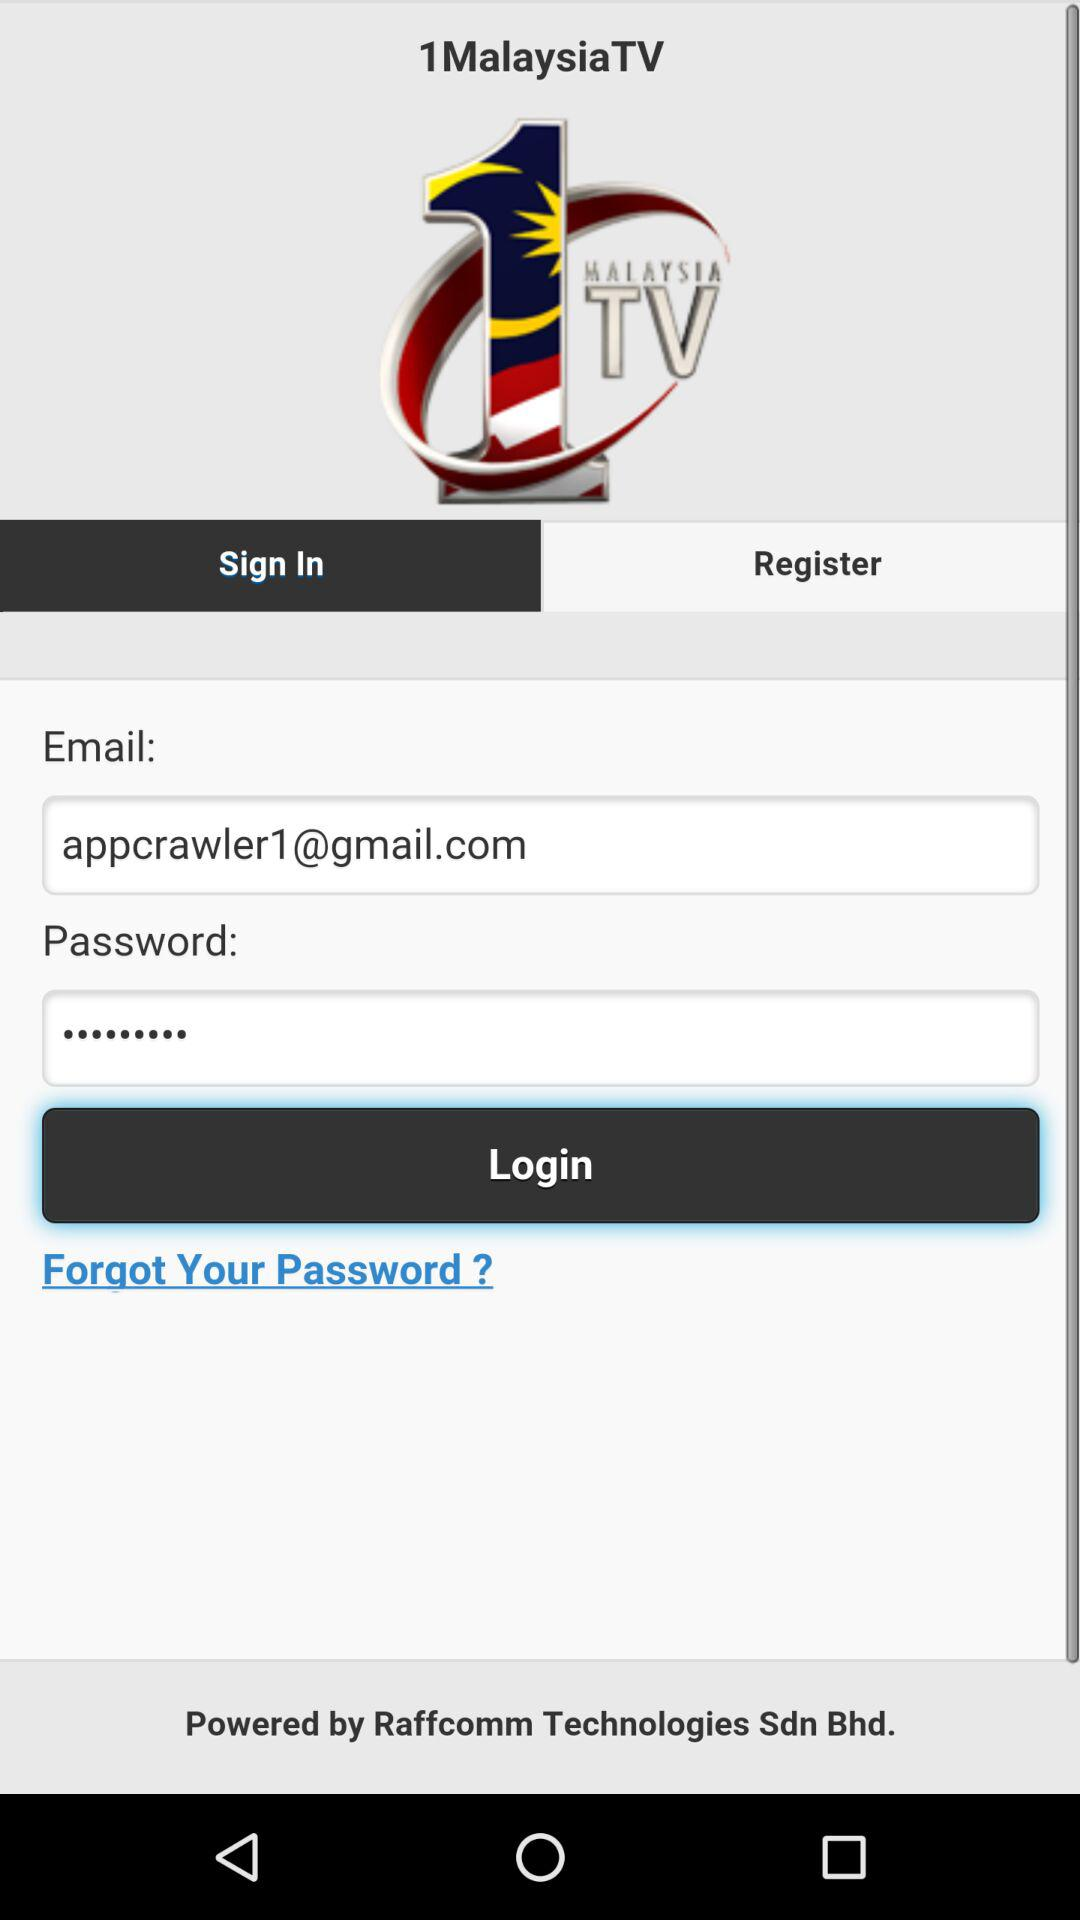Which tab is selected? The selected tab is "Sign In". 